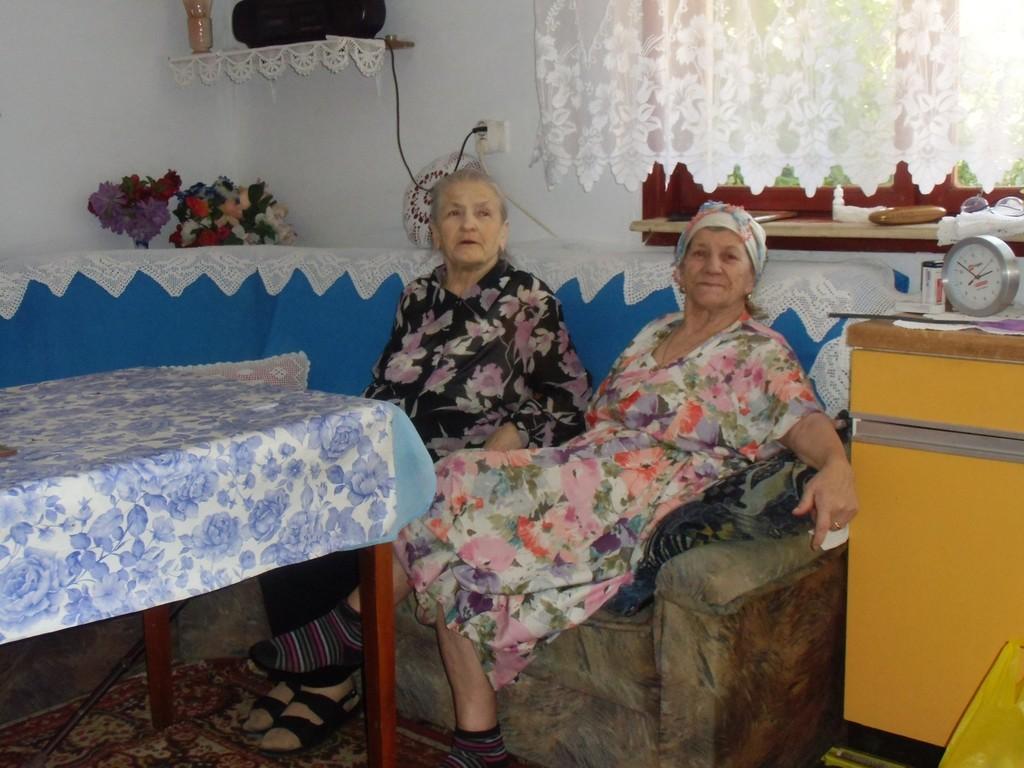In one or two sentences, can you explain what this image depicts? This picture shows two women seated on the sofa and we see a table and a clock 